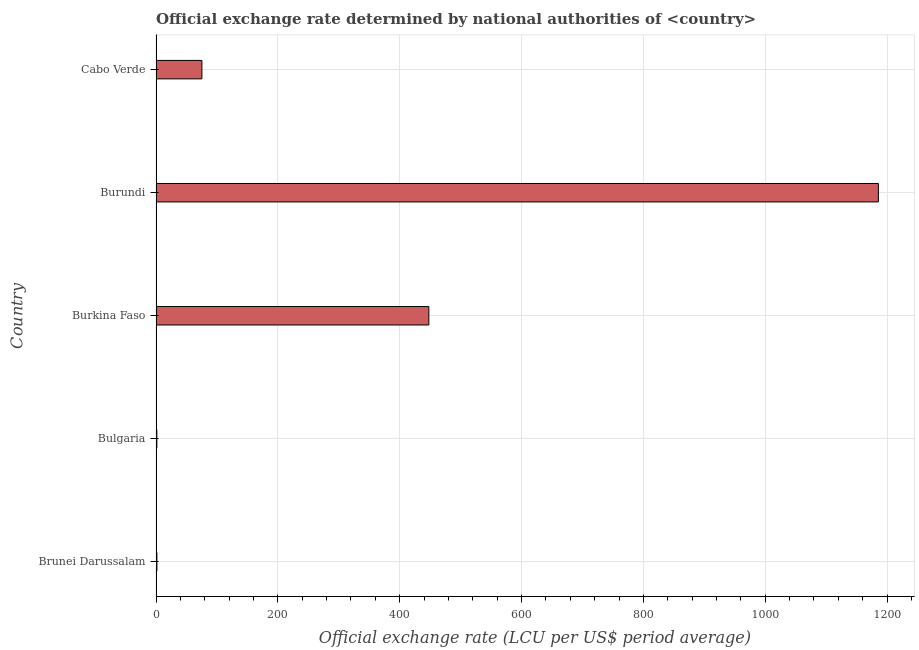Does the graph contain any zero values?
Your answer should be very brief. No. Does the graph contain grids?
Your answer should be compact. Yes. What is the title of the graph?
Offer a terse response. Official exchange rate determined by national authorities of <country>. What is the label or title of the X-axis?
Your response must be concise. Official exchange rate (LCU per US$ period average). What is the official exchange rate in Burkina Faso?
Provide a short and direct response. 447.81. Across all countries, what is the maximum official exchange rate?
Offer a very short reply. 1185.69. Across all countries, what is the minimum official exchange rate?
Your answer should be compact. 1.34. In which country was the official exchange rate maximum?
Make the answer very short. Burundi. What is the sum of the official exchange rate?
Your response must be concise. 1711.53. What is the difference between the official exchange rate in Brunei Darussalam and Burundi?
Keep it short and to the point. -1184.27. What is the average official exchange rate per country?
Provide a succinct answer. 342.31. What is the median official exchange rate?
Your answer should be very brief. 75.28. What is the ratio of the official exchange rate in Brunei Darussalam to that in Burkina Faso?
Your answer should be compact. 0. Is the official exchange rate in Burkina Faso less than that in Burundi?
Your response must be concise. Yes. Is the difference between the official exchange rate in Brunei Darussalam and Burundi greater than the difference between any two countries?
Keep it short and to the point. No. What is the difference between the highest and the second highest official exchange rate?
Your answer should be very brief. 737.89. What is the difference between the highest and the lowest official exchange rate?
Offer a very short reply. 1184.35. Are the values on the major ticks of X-axis written in scientific E-notation?
Your response must be concise. No. What is the Official exchange rate (LCU per US$ period average) of Brunei Darussalam?
Ensure brevity in your answer.  1.42. What is the Official exchange rate (LCU per US$ period average) in Bulgaria?
Provide a short and direct response. 1.34. What is the Official exchange rate (LCU per US$ period average) of Burkina Faso?
Offer a very short reply. 447.81. What is the Official exchange rate (LCU per US$ period average) of Burundi?
Offer a very short reply. 1185.69. What is the Official exchange rate (LCU per US$ period average) of Cabo Verde?
Your answer should be very brief. 75.28. What is the difference between the Official exchange rate (LCU per US$ period average) in Brunei Darussalam and Bulgaria?
Give a very brief answer. 0.08. What is the difference between the Official exchange rate (LCU per US$ period average) in Brunei Darussalam and Burkina Faso?
Provide a short and direct response. -446.39. What is the difference between the Official exchange rate (LCU per US$ period average) in Brunei Darussalam and Burundi?
Provide a succinct answer. -1184.27. What is the difference between the Official exchange rate (LCU per US$ period average) in Brunei Darussalam and Cabo Verde?
Offer a terse response. -73.86. What is the difference between the Official exchange rate (LCU per US$ period average) in Bulgaria and Burkina Faso?
Make the answer very short. -446.47. What is the difference between the Official exchange rate (LCU per US$ period average) in Bulgaria and Burundi?
Keep it short and to the point. -1184.35. What is the difference between the Official exchange rate (LCU per US$ period average) in Bulgaria and Cabo Verde?
Your answer should be very brief. -73.94. What is the difference between the Official exchange rate (LCU per US$ period average) in Burkina Faso and Burundi?
Give a very brief answer. -737.89. What is the difference between the Official exchange rate (LCU per US$ period average) in Burkina Faso and Cabo Verde?
Your answer should be very brief. 372.53. What is the difference between the Official exchange rate (LCU per US$ period average) in Burundi and Cabo Verde?
Give a very brief answer. 1110.41. What is the ratio of the Official exchange rate (LCU per US$ period average) in Brunei Darussalam to that in Bulgaria?
Give a very brief answer. 1.06. What is the ratio of the Official exchange rate (LCU per US$ period average) in Brunei Darussalam to that in Burkina Faso?
Ensure brevity in your answer.  0. What is the ratio of the Official exchange rate (LCU per US$ period average) in Brunei Darussalam to that in Burundi?
Provide a short and direct response. 0. What is the ratio of the Official exchange rate (LCU per US$ period average) in Brunei Darussalam to that in Cabo Verde?
Provide a succinct answer. 0.02. What is the ratio of the Official exchange rate (LCU per US$ period average) in Bulgaria to that in Burkina Faso?
Offer a very short reply. 0. What is the ratio of the Official exchange rate (LCU per US$ period average) in Bulgaria to that in Cabo Verde?
Your response must be concise. 0.02. What is the ratio of the Official exchange rate (LCU per US$ period average) in Burkina Faso to that in Burundi?
Ensure brevity in your answer.  0.38. What is the ratio of the Official exchange rate (LCU per US$ period average) in Burkina Faso to that in Cabo Verde?
Your response must be concise. 5.95. What is the ratio of the Official exchange rate (LCU per US$ period average) in Burundi to that in Cabo Verde?
Provide a short and direct response. 15.75. 